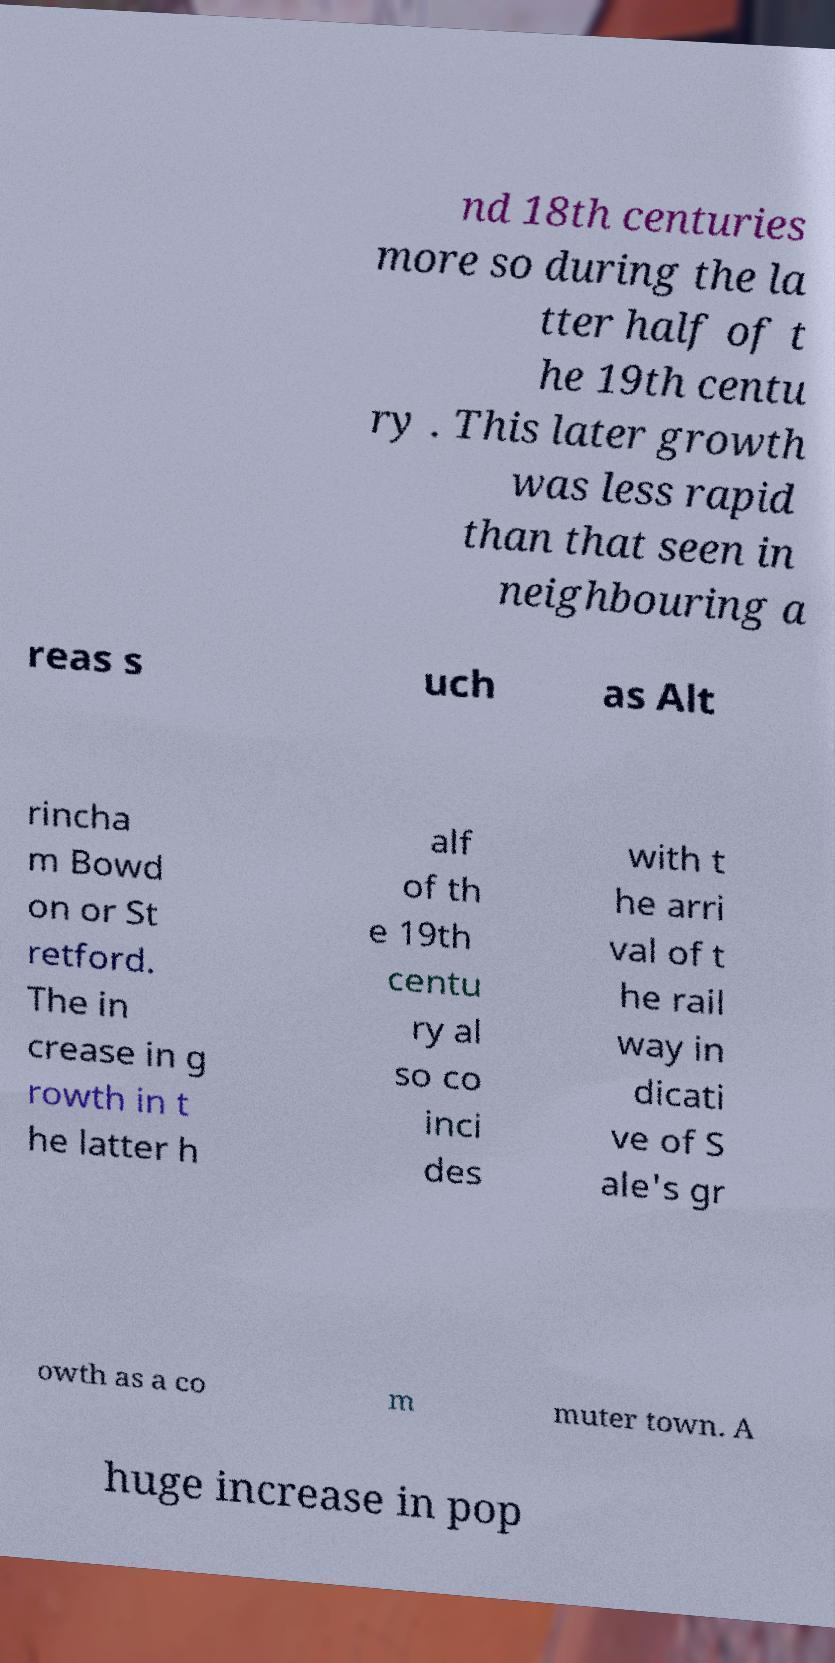I need the written content from this picture converted into text. Can you do that? nd 18th centuries more so during the la tter half of t he 19th centu ry . This later growth was less rapid than that seen in neighbouring a reas s uch as Alt rincha m Bowd on or St retford. The in crease in g rowth in t he latter h alf of th e 19th centu ry al so co inci des with t he arri val of t he rail way in dicati ve of S ale's gr owth as a co m muter town. A huge increase in pop 